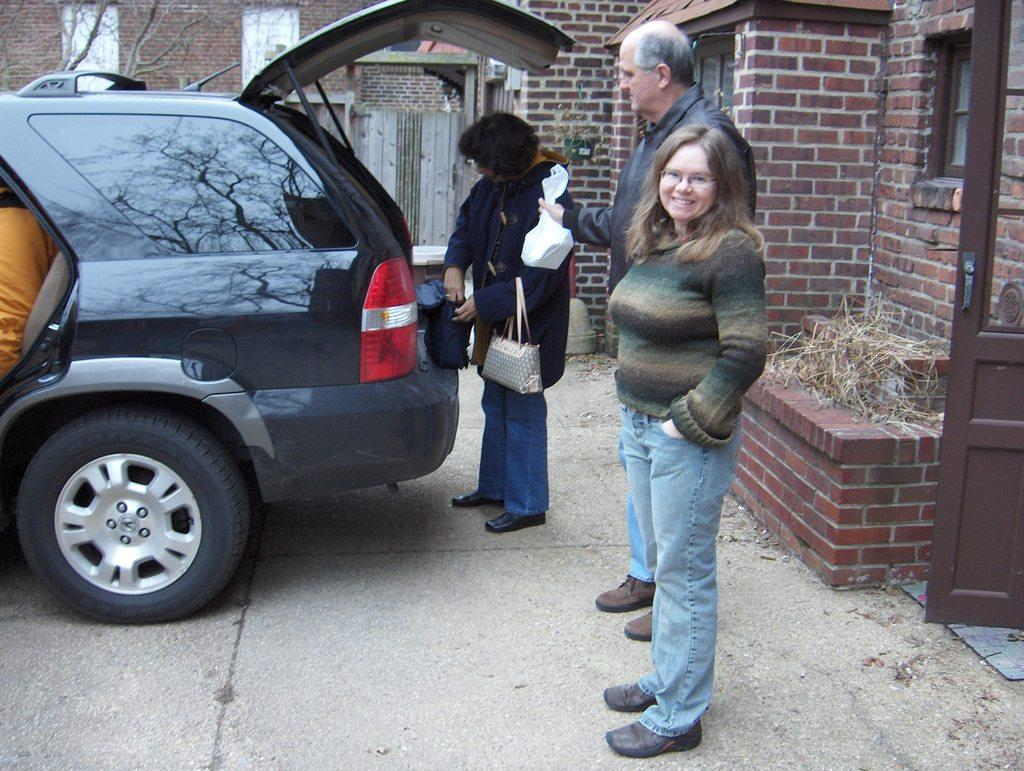How many people are in the image? There are three persons standing in the image. What else can be seen in the image besides the people? There is a vehicle and branches visible in the image. What is in the background of the image? There is a building in the background of the image. What type of minister is depicted in the image? There is no minister present in the image. How many bees can be seen buzzing around the vehicle in the image? There are no bees present in the image. 